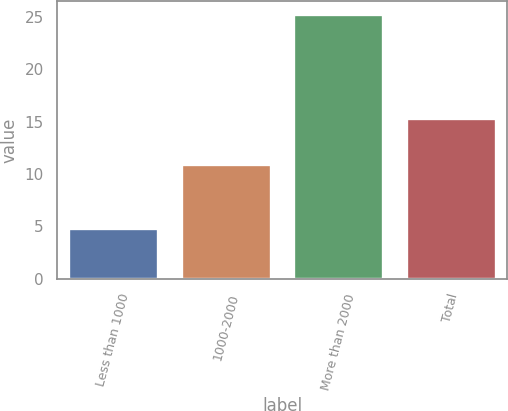Convert chart to OTSL. <chart><loc_0><loc_0><loc_500><loc_500><bar_chart><fcel>Less than 1000<fcel>1000-2000<fcel>More than 2000<fcel>Total<nl><fcel>4.87<fcel>10.97<fcel>25.24<fcel>15.31<nl></chart> 